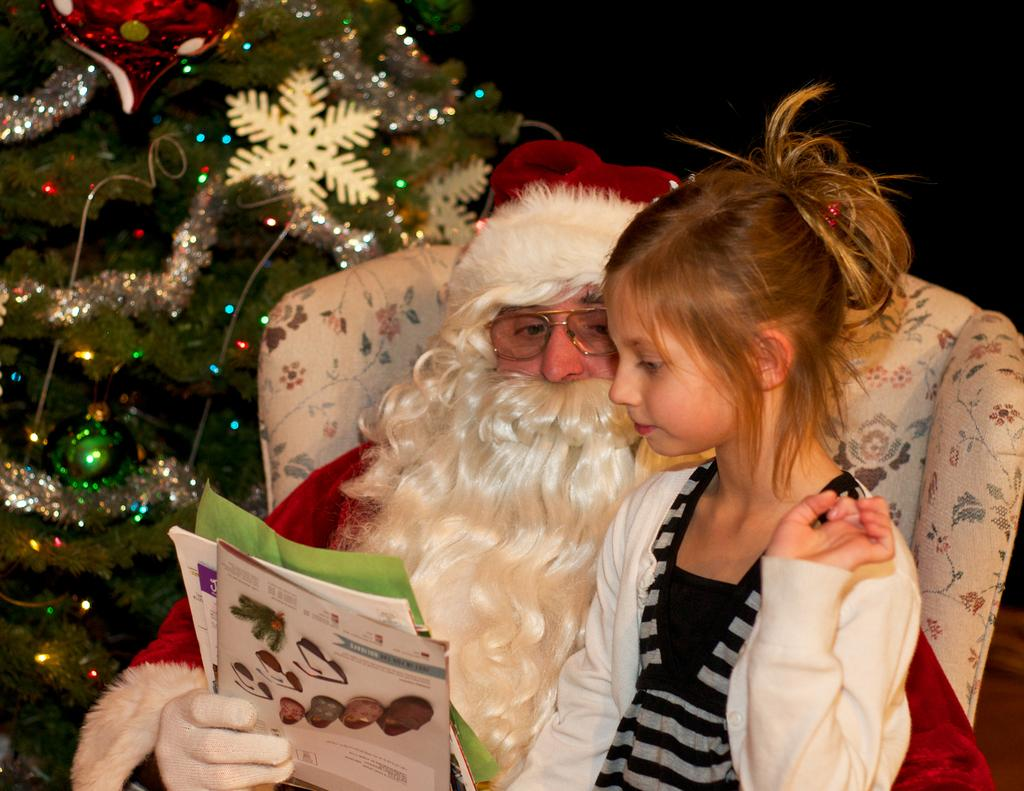Who is present in the picture with Santa Claus? There is a girl in the picture, and she is sitting with Santa Claus on the couch. What is Santa Claus doing in the picture? Santa Claus is sitting on a couch and holding papers. What can be seen on the left side of the image? There is a decorated Christmas tree on the left side of the image. How would you describe the lighting in the image? The background of the image is dark. What type of yam is being used as a pillow for the girl in the image? There is no yam present in the image, and the girl is not using a yam as a pillow. 